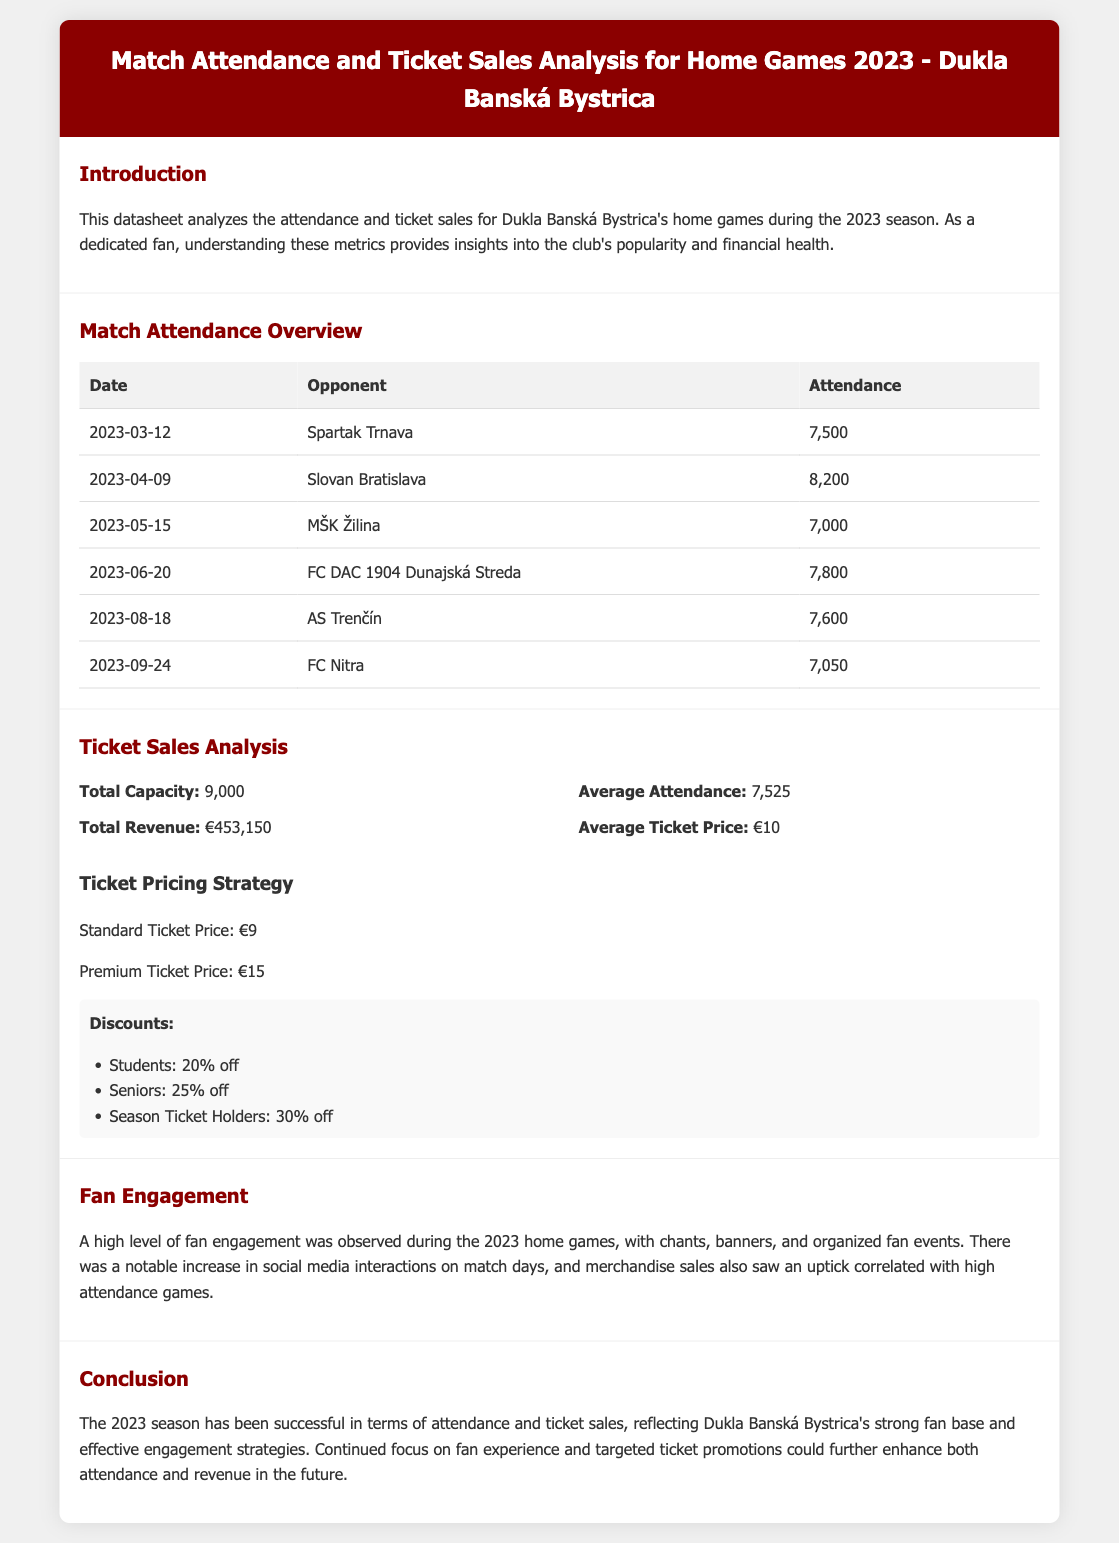What was the highest attendance recorded? The highest attendance recorded in the document is during the match against Slovan Bratislava on April 9, 2023.
Answer: 8,200 What is the average ticket price? The average ticket price is stated in the ticket sales analysis section of the document.
Answer: €10 Who was the opponent on March 12, 2023? The opponent for the match on March 12, 2023, is listed in the attendance overview table.
Answer: Spartak Trnava What is the total capacity of the stadium? The total capacity is provided in the ticket sales analysis section of the document.
Answer: 9,000 What was the total revenue for the season? The total revenue is specified in the ticket sales analysis section and reflects ticket sales for the home games.
Answer: €453,150 Which match had the lowest attendance? The match with the lowest attendance can be determined from the attendance overview table presented in the document.
Answer: MŠK Žilina What discount do season ticket holders receive? The document outlines various discounts, including the specific discount for season ticket holders.
Answer: 30% off How many matches were analyzed in the attendance overview? The number of matches can be counted from the rows in the match attendance table in the document.
Answer: 6 